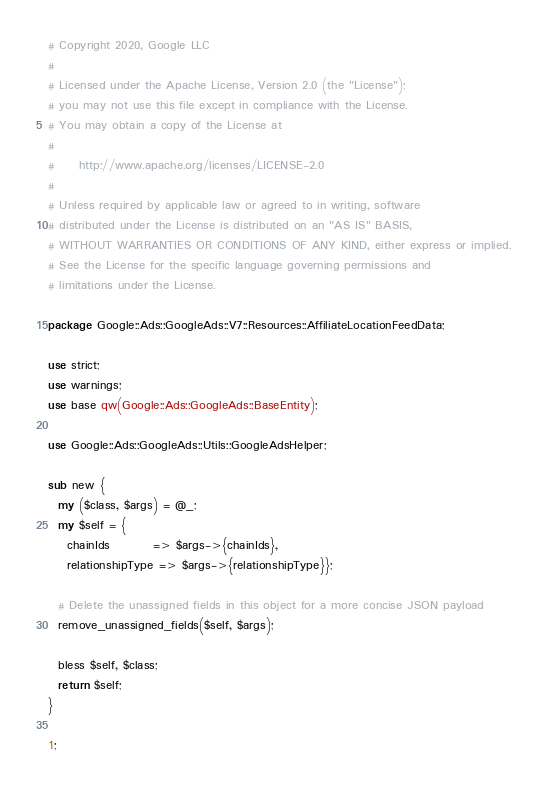Convert code to text. <code><loc_0><loc_0><loc_500><loc_500><_Perl_># Copyright 2020, Google LLC
#
# Licensed under the Apache License, Version 2.0 (the "License");
# you may not use this file except in compliance with the License.
# You may obtain a copy of the License at
#
#     http://www.apache.org/licenses/LICENSE-2.0
#
# Unless required by applicable law or agreed to in writing, software
# distributed under the License is distributed on an "AS IS" BASIS,
# WITHOUT WARRANTIES OR CONDITIONS OF ANY KIND, either express or implied.
# See the License for the specific language governing permissions and
# limitations under the License.

package Google::Ads::GoogleAds::V7::Resources::AffiliateLocationFeedData;

use strict;
use warnings;
use base qw(Google::Ads::GoogleAds::BaseEntity);

use Google::Ads::GoogleAds::Utils::GoogleAdsHelper;

sub new {
  my ($class, $args) = @_;
  my $self = {
    chainIds         => $args->{chainIds},
    relationshipType => $args->{relationshipType}};

  # Delete the unassigned fields in this object for a more concise JSON payload
  remove_unassigned_fields($self, $args);

  bless $self, $class;
  return $self;
}

1;
</code> 